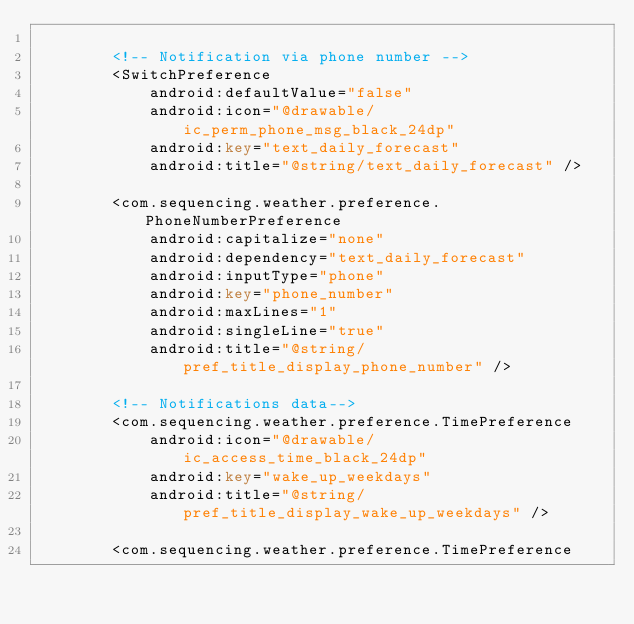<code> <loc_0><loc_0><loc_500><loc_500><_XML_>
        <!-- Notification via phone number -->
        <SwitchPreference
            android:defaultValue="false"
            android:icon="@drawable/ic_perm_phone_msg_black_24dp"
            android:key="text_daily_forecast"
            android:title="@string/text_daily_forecast" />

        <com.sequencing.weather.preference.PhoneNumberPreference
            android:capitalize="none"
            android:dependency="text_daily_forecast"
            android:inputType="phone"
            android:key="phone_number"
            android:maxLines="1"
            android:singleLine="true"
            android:title="@string/pref_title_display_phone_number" />

        <!-- Notifications data-->
        <com.sequencing.weather.preference.TimePreference
            android:icon="@drawable/ic_access_time_black_24dp"
            android:key="wake_up_weekdays"
            android:title="@string/pref_title_display_wake_up_weekdays" />

        <com.sequencing.weather.preference.TimePreference</code> 